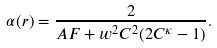Convert formula to latex. <formula><loc_0><loc_0><loc_500><loc_500>\alpha ( r ) = \frac { 2 } { A F + w ^ { 2 } C ^ { 2 } ( 2 C ^ { \kappa } - 1 ) } .</formula> 